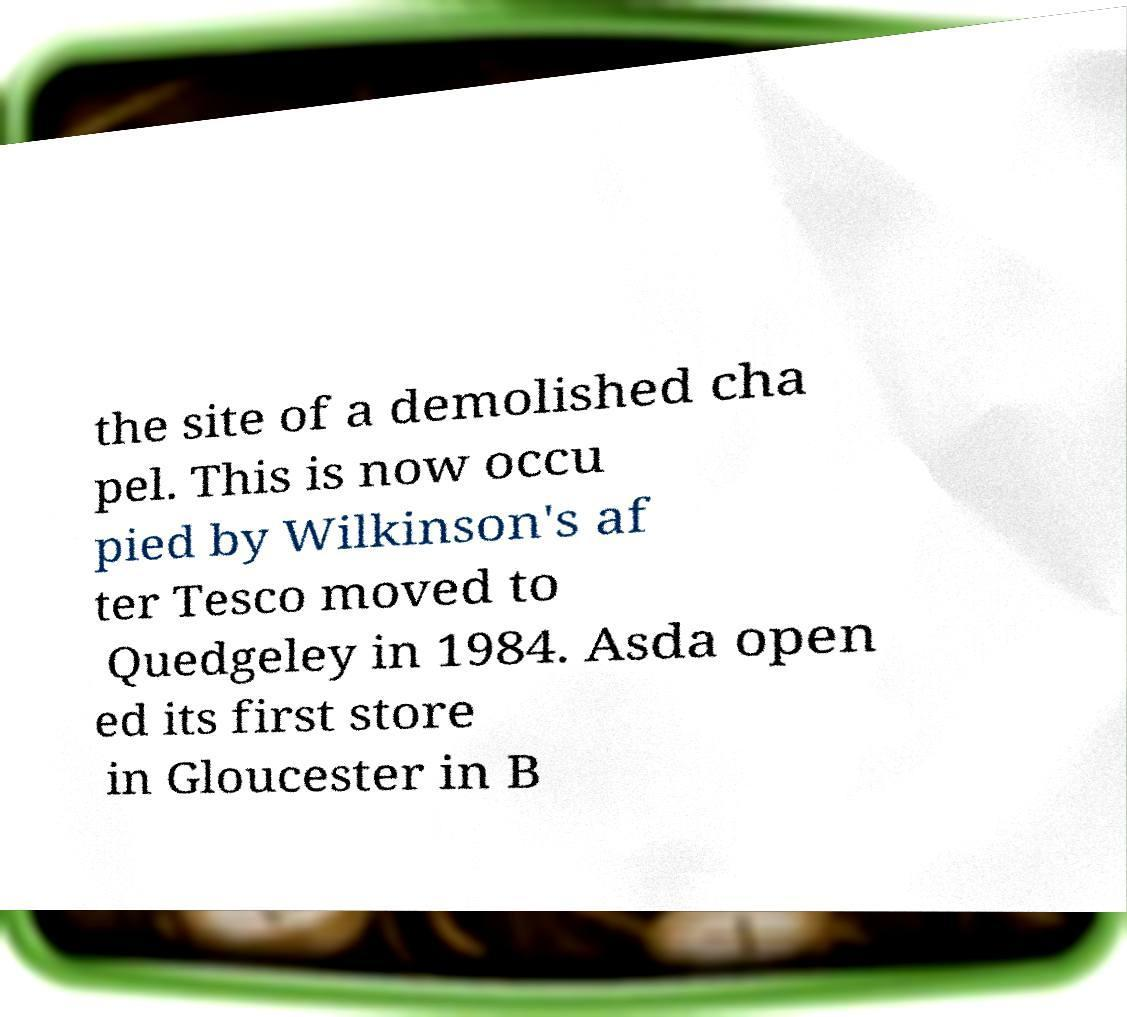Could you assist in decoding the text presented in this image and type it out clearly? the site of a demolished cha pel. This is now occu pied by Wilkinson's af ter Tesco moved to Quedgeley in 1984. Asda open ed its first store in Gloucester in B 